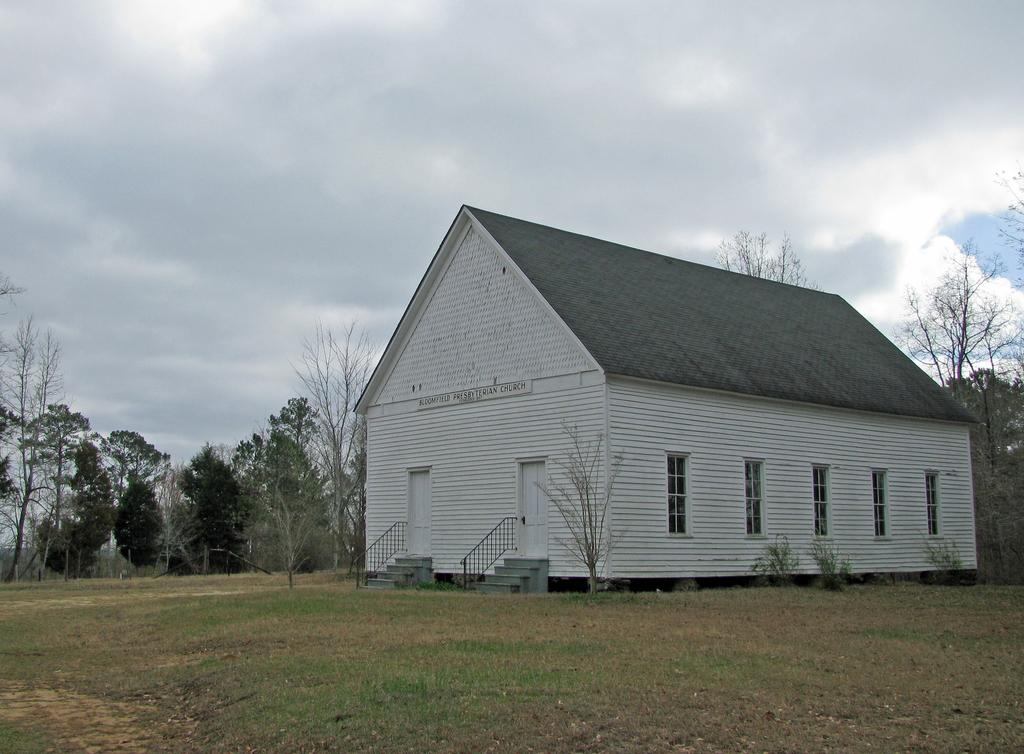What type of vegetation is at the bottom of the image? There is grass at the bottom of the image. What can be seen in the middle of the image? There are plants, a house, and trees in the middle of the image. Can you describe the sky in the image? The sky is visible at the top of the image, and there are clouds visible. What shape is the patch of grass in the image? There is no patch of grass mentioned in the image; it simply states that there is grass at the bottom of the image. How does the house get washed in the image? The image does not depict any washing of the house; it only shows the house in the middle of the image. 